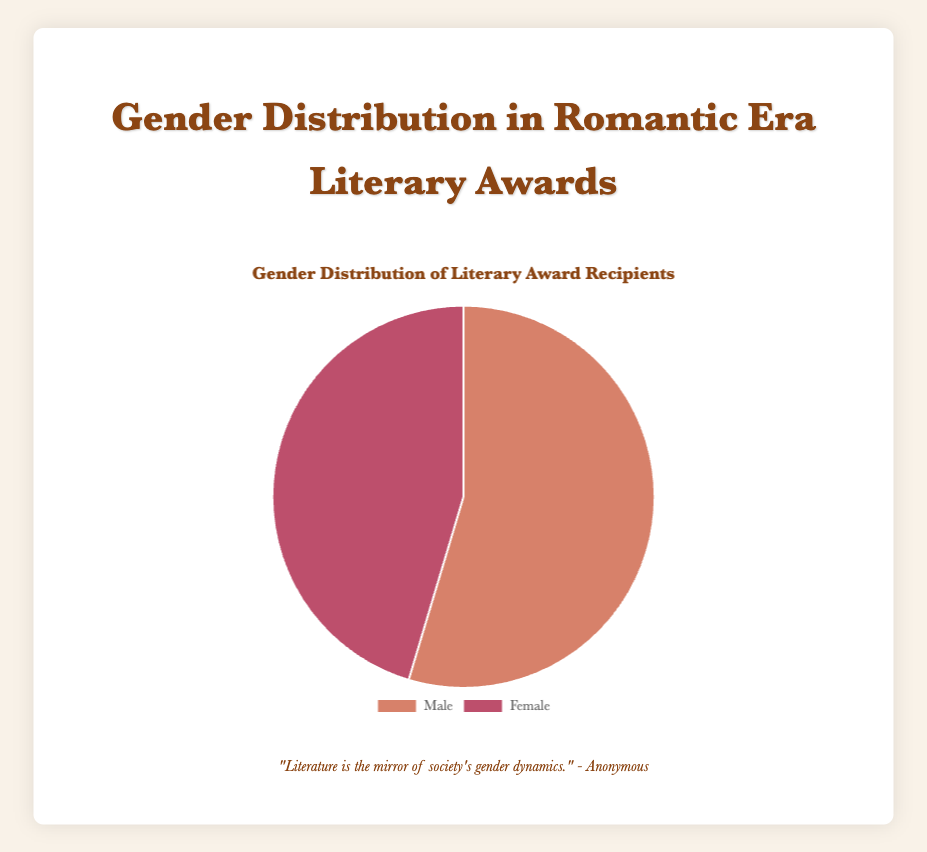What is the total number of awards won by males? Sum the counts of awards won by males from the data: 15 (Pulitzer) + 8 (Nobel) + 13 (National Book Award) + 12 (Hugo) + 11 (Booker) = 59
Answer: 59 What is the gender distribution ratio for the Pulitzer Prize for Fiction? Divide the counts for each gender by the total number of awards for the Pulitzer Prize for Fiction: Male: 15/(15+10) and Female: 10/(15+10). The ratio is 15:10
Answer: 3:2 Which gender won more Nobel Prizes in Literature? Compare the counts for the Nobel Prize in Literature: 8 (Male) versus 3 (Female). Males won more
Answer: Male What percentage of National Book Award for Fiction recipients are female? Calculate the percentage: (7 / (13 + 7)) * 100. Therefore, (7 / 20) * 100 = 35%
Answer: 35% How does the total number of awards won by females compare to the total won by males? Compare the total counts of awards won by each gender: Females = 10 (Pulitzer) + 3 (Nobel) + 7 (National Book Award) + 5 (Hugo) + 4 (Booker) + 20 (Baileys) = 49; Males = 59. Hence, females won fewer awards
Answer: Females won fewer In which award category do males have the highest count of wins? Compare male counts in each category: Pulitzer (15), Nobel (8), National Book Award (13), Hugo (12), Booker (11). Pulitzers have the highest count with 15
Answer: Pulitzer Prize for Fiction What is the combined percentage of awards won by females in Hugo Award for Best Novel and Booker Prize? Find the total counts of these awards won by both genders, then calculate the female percentage. Hugo: 5/(5+12), Booker: 4/(4+11). Calculate combined awards for females: 5 + 4 = 9; Total: 5+12+4+11 = 32; (9/32) * 100 = 28.13%
Answer: 28.13% What’s the most exclusive female-only award category shown in the data? Identify the dataset with females only: Baileys Women’s Prize for Fiction has only female awards with a count of 20
Answer: Baileys Women's Prize for Fiction 